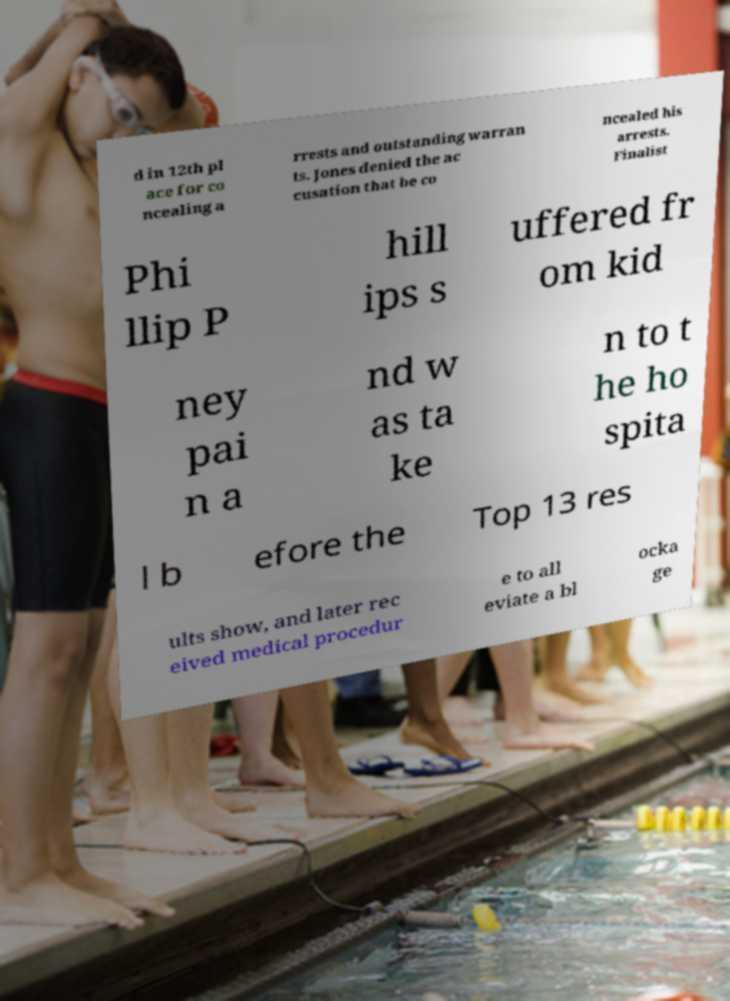Can you read and provide the text displayed in the image?This photo seems to have some interesting text. Can you extract and type it out for me? d in 12th pl ace for co ncealing a rrests and outstanding warran ts. Jones denied the ac cusation that he co ncealed his arrests. Finalist Phi llip P hill ips s uffered fr om kid ney pai n a nd w as ta ke n to t he ho spita l b efore the Top 13 res ults show, and later rec eived medical procedur e to all eviate a bl ocka ge 